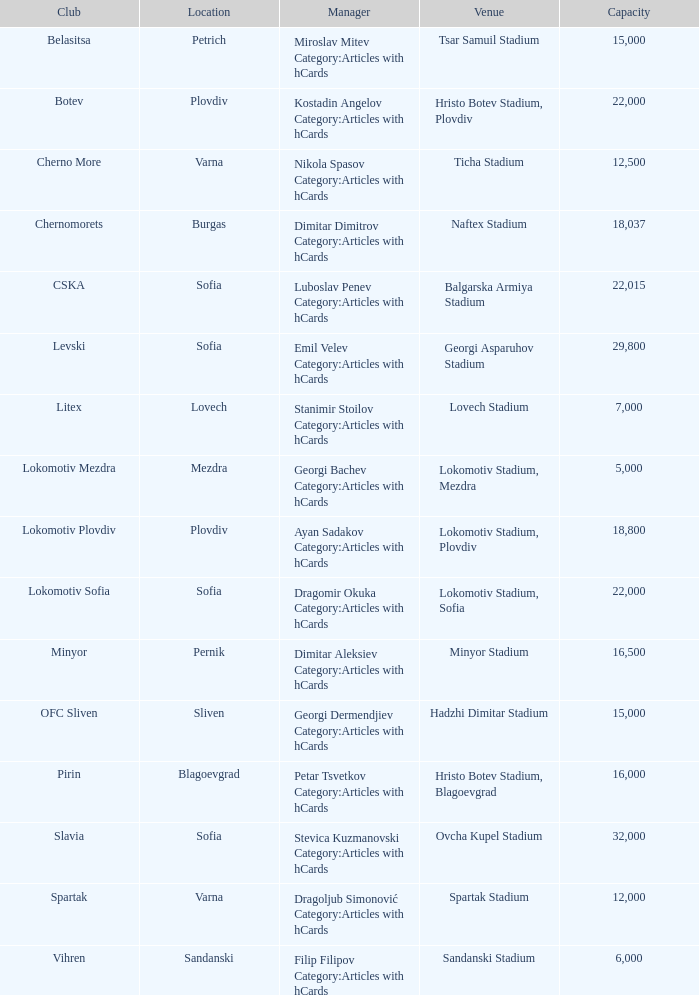What is the maximum capacity for the vihren club's venue? 6000.0. 